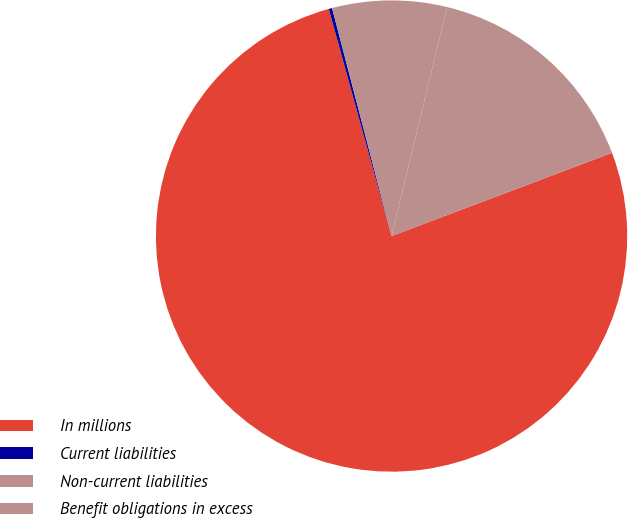Convert chart. <chart><loc_0><loc_0><loc_500><loc_500><pie_chart><fcel>In millions<fcel>Current liabilities<fcel>Non-current liabilities<fcel>Benefit obligations in excess<nl><fcel>76.45%<fcel>0.23%<fcel>7.85%<fcel>15.47%<nl></chart> 